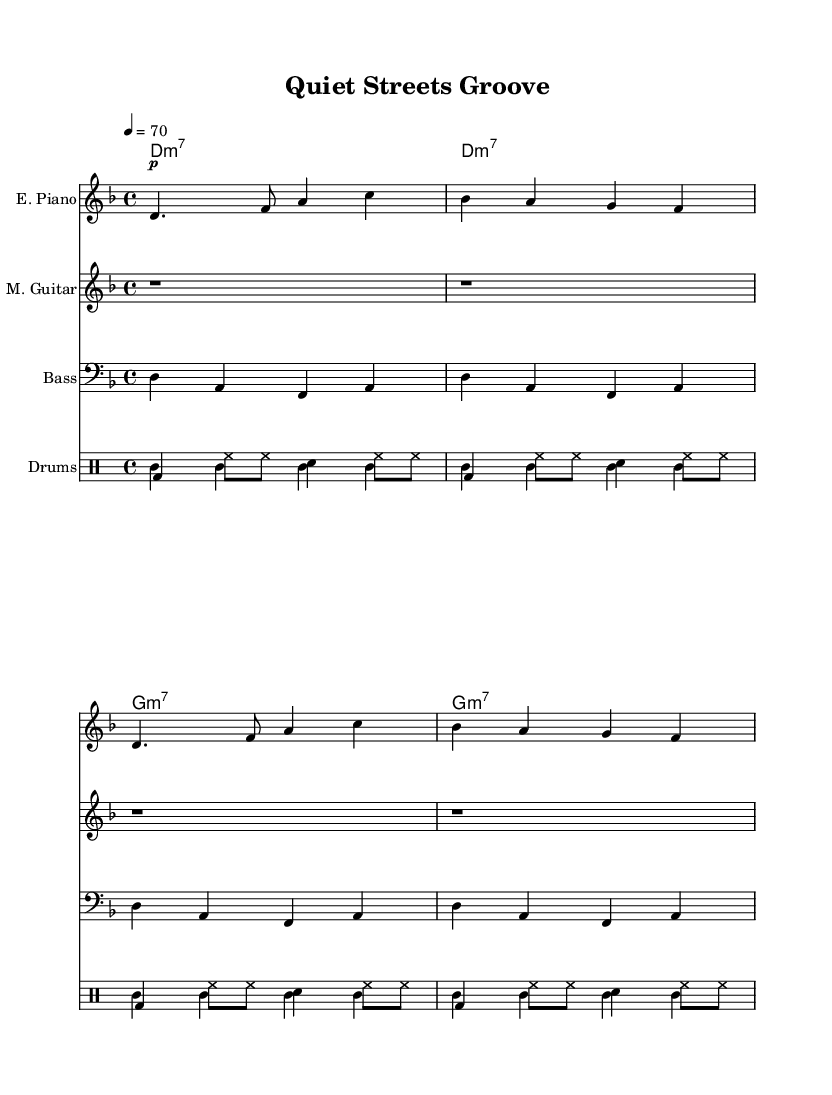What is the key signature of this music? The key signature indicates that this piece is in D minor, which has one flat (B flat). This can be found at the beginning of the sheet music where the sharps or flats are marked.
Answer: D minor What is the time signature of this music? The time signature is found at the beginning of the score, shown as 4/4, meaning there are four beats per measure and the quarter note gets one beat.
Answer: 4/4 What is the tempo marking for this piece? The tempo marking is indicated at the start of the score, which is noted as "4 = 70," specifying that there are 70 quarter note beats in a minute.
Answer: 70 How many measures does the electric piano part have? By examining the electric piano part in the sheet music, it is clear that there are four measures, as counted by the grouping of vertical bar lines.
Answer: 4 What type of guitar is indicated in this piece? The guitar part is labeled as "Muted Guitar," which suggests that the playing technique is altered to produce a softer and more subdued sound, typical in funk music for a smoother vibe.
Answer: Muted What rhythmic pattern is used in the brushed drums? The brushed drums exhibit a standard funk rhythm with a combination of bass drum and hi-hat played in a pattern creating a swinging feel, indicating typical funk drum patterns.
Answer: Funk pattern What instrument plays the bass part? The bass part is labeled as "Bass," and upon visual inspection, it shows a fretless bass line which contributes to the smooth and mellow sound associated with funk.
Answer: Fretless bass 